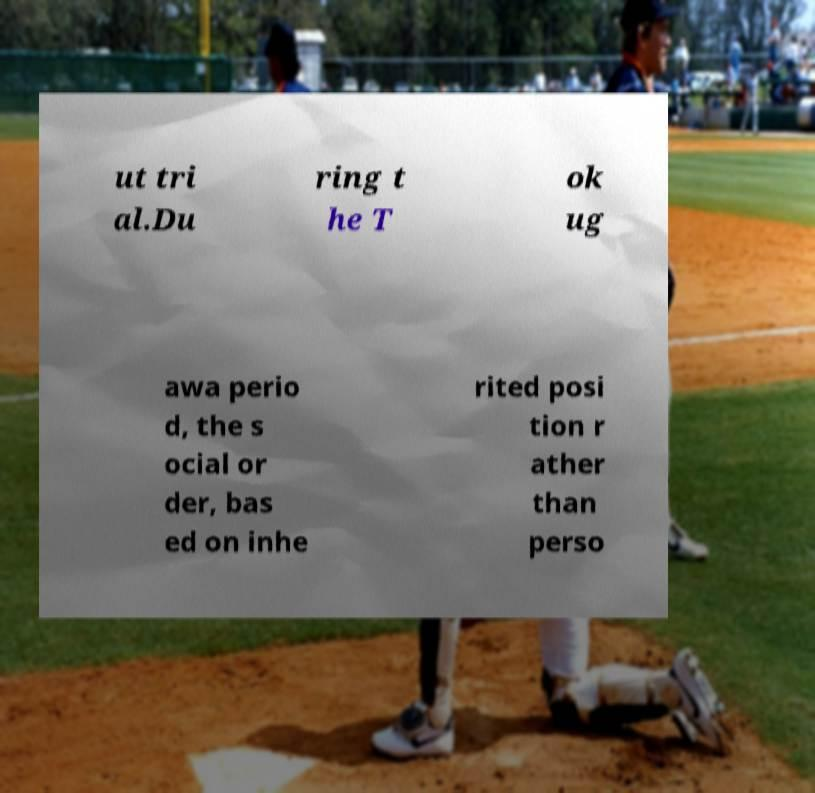Can you read and provide the text displayed in the image?This photo seems to have some interesting text. Can you extract and type it out for me? ut tri al.Du ring t he T ok ug awa perio d, the s ocial or der, bas ed on inhe rited posi tion r ather than perso 